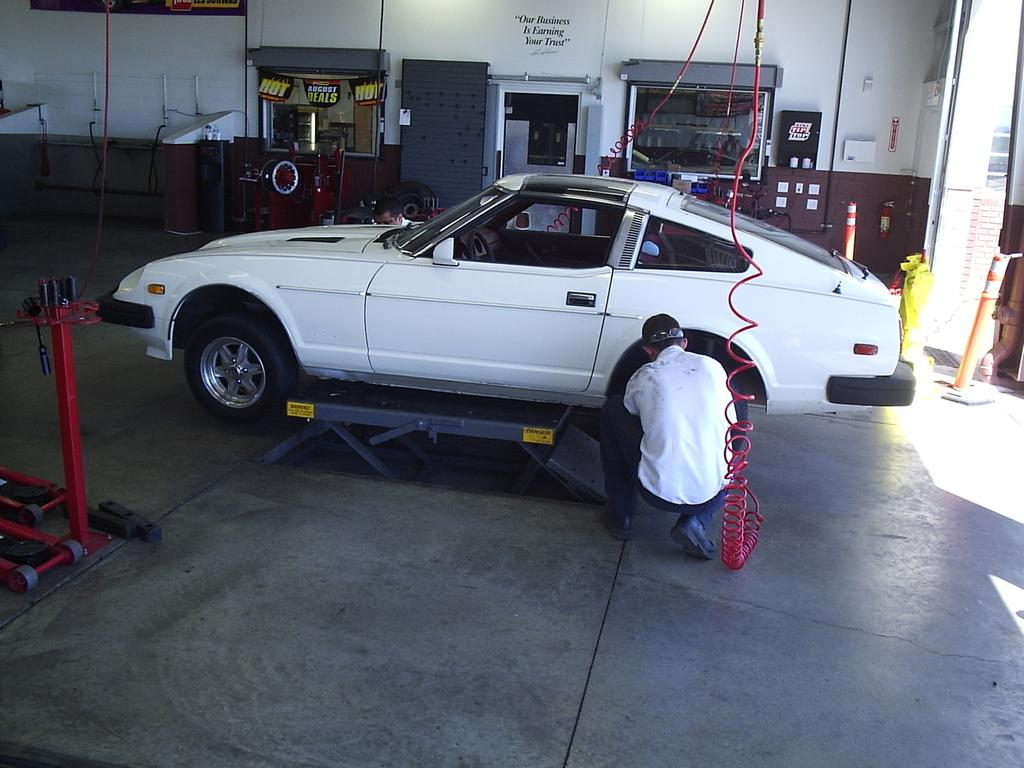What is the main subject of the image? The main subject of the image is a car. Can you describe the car in the image? The car is white. What is the man in the image doing? The man is repairing the car. What is the man wearing while repairing the car? The man is wearing a white dress. How many eggs are visible in the image? There are no eggs present in the image. What type of approval is the man seeking for his car repair work in the image? There is no indication in the image that the man is seeking any approval for his car repair work. 